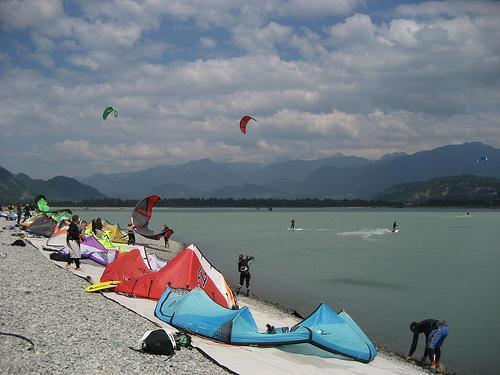How many parasails are up in the air in the image?
Give a very brief answer. 2. 